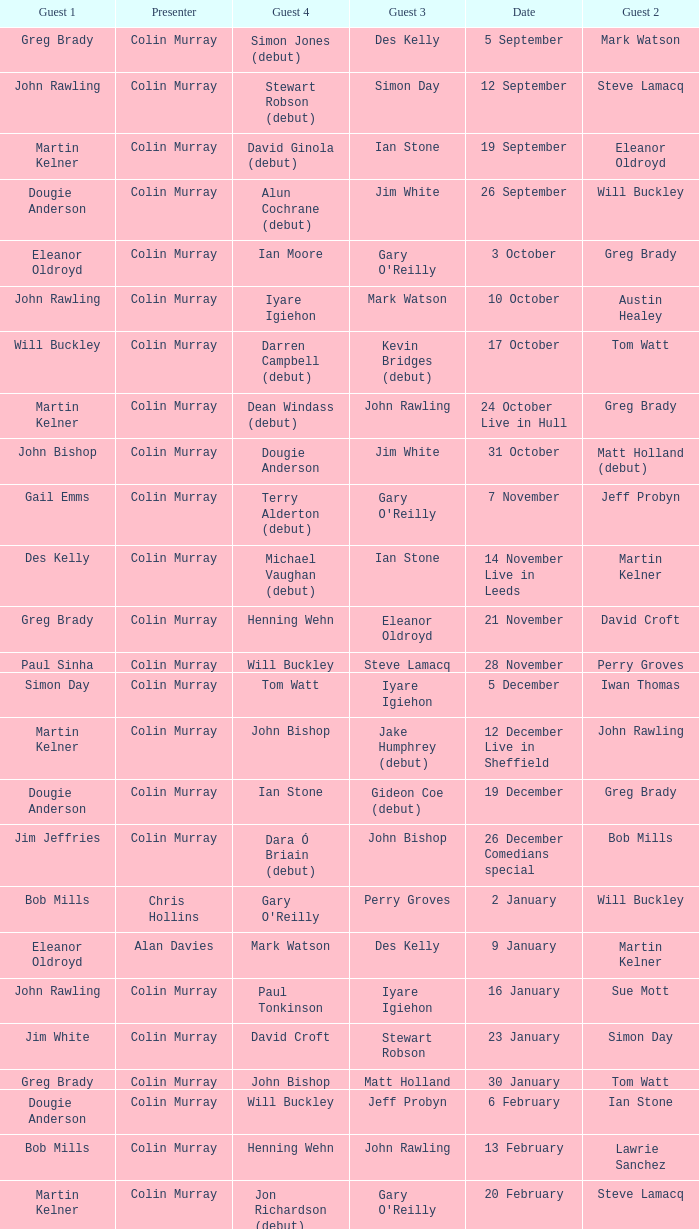On episodes where guest 1 is Jim White, who was guest 3? Stewart Robson. 